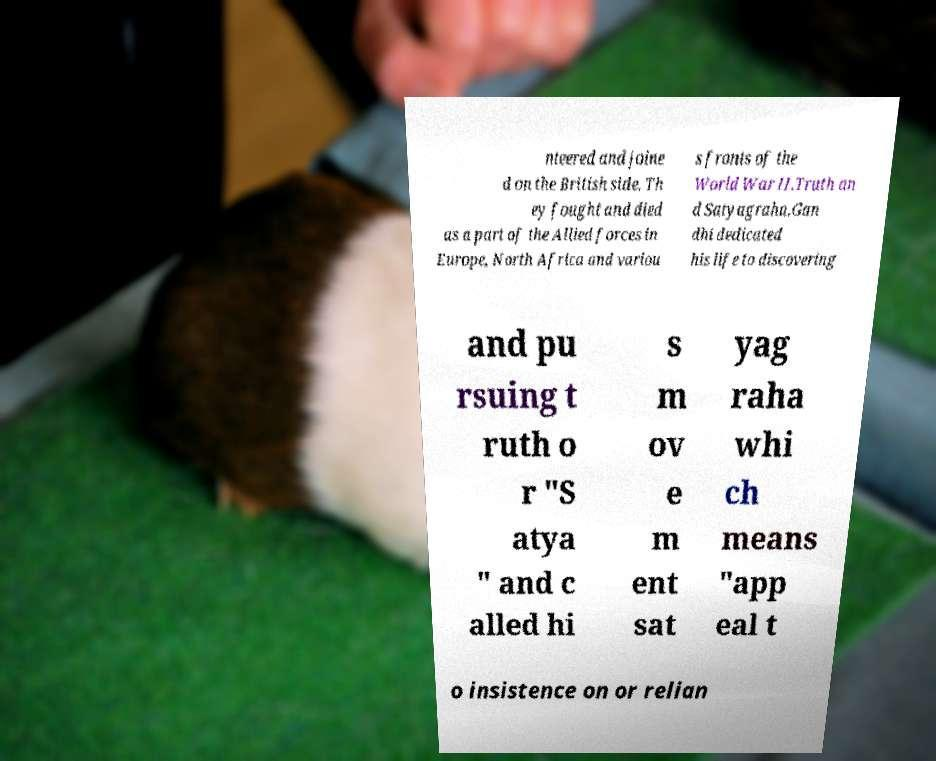Can you accurately transcribe the text from the provided image for me? nteered and joine d on the British side. Th ey fought and died as a part of the Allied forces in Europe, North Africa and variou s fronts of the World War II.Truth an d Satyagraha.Gan dhi dedicated his life to discovering and pu rsuing t ruth o r "S atya " and c alled hi s m ov e m ent sat yag raha whi ch means "app eal t o insistence on or relian 